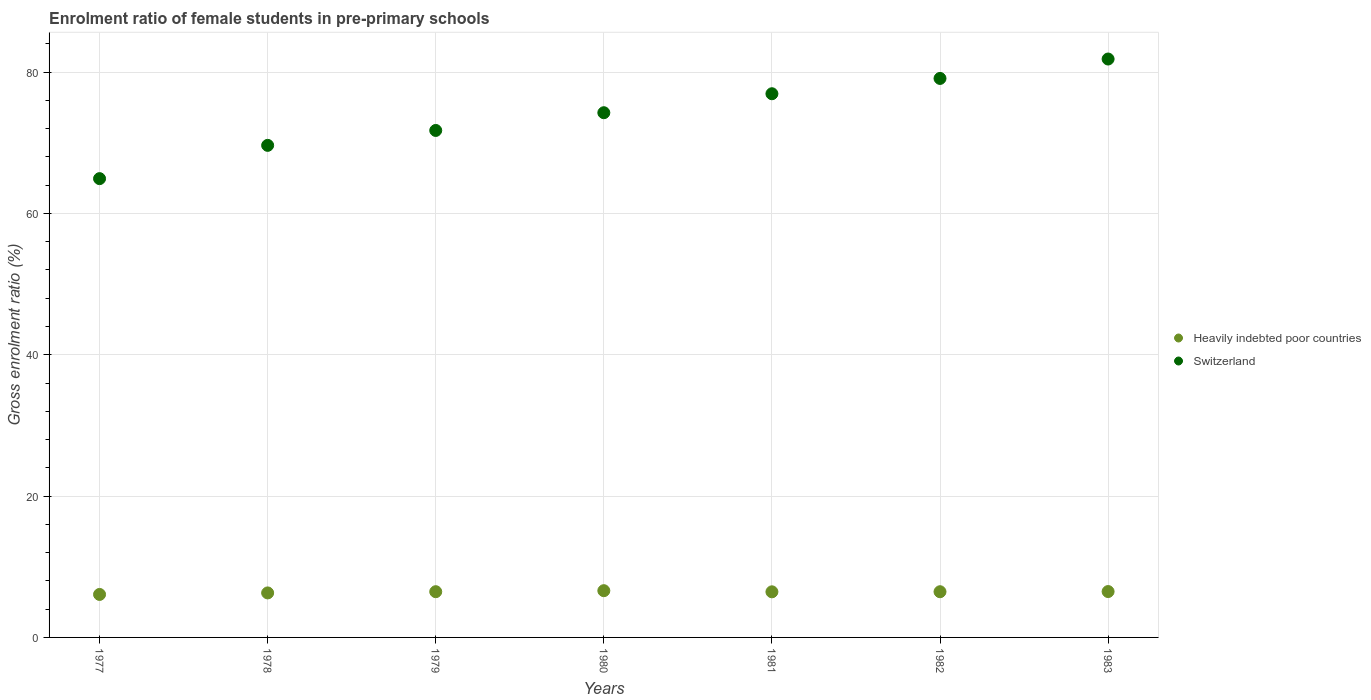Is the number of dotlines equal to the number of legend labels?
Offer a terse response. Yes. What is the enrolment ratio of female students in pre-primary schools in Heavily indebted poor countries in 1979?
Give a very brief answer. 6.47. Across all years, what is the maximum enrolment ratio of female students in pre-primary schools in Switzerland?
Give a very brief answer. 81.85. Across all years, what is the minimum enrolment ratio of female students in pre-primary schools in Switzerland?
Your answer should be compact. 64.92. In which year was the enrolment ratio of female students in pre-primary schools in Heavily indebted poor countries maximum?
Your answer should be compact. 1980. In which year was the enrolment ratio of female students in pre-primary schools in Heavily indebted poor countries minimum?
Offer a very short reply. 1977. What is the total enrolment ratio of female students in pre-primary schools in Heavily indebted poor countries in the graph?
Offer a very short reply. 44.88. What is the difference between the enrolment ratio of female students in pre-primary schools in Heavily indebted poor countries in 1978 and that in 1981?
Provide a short and direct response. -0.16. What is the difference between the enrolment ratio of female students in pre-primary schools in Heavily indebted poor countries in 1981 and the enrolment ratio of female students in pre-primary schools in Switzerland in 1982?
Provide a succinct answer. -72.65. What is the average enrolment ratio of female students in pre-primary schools in Heavily indebted poor countries per year?
Offer a very short reply. 6.41. In the year 1978, what is the difference between the enrolment ratio of female students in pre-primary schools in Switzerland and enrolment ratio of female students in pre-primary schools in Heavily indebted poor countries?
Offer a very short reply. 63.33. What is the ratio of the enrolment ratio of female students in pre-primary schools in Heavily indebted poor countries in 1977 to that in 1979?
Offer a terse response. 0.94. Is the enrolment ratio of female students in pre-primary schools in Switzerland in 1977 less than that in 1983?
Keep it short and to the point. Yes. Is the difference between the enrolment ratio of female students in pre-primary schools in Switzerland in 1978 and 1980 greater than the difference between the enrolment ratio of female students in pre-primary schools in Heavily indebted poor countries in 1978 and 1980?
Your response must be concise. No. What is the difference between the highest and the second highest enrolment ratio of female students in pre-primary schools in Heavily indebted poor countries?
Keep it short and to the point. 0.12. What is the difference between the highest and the lowest enrolment ratio of female students in pre-primary schools in Switzerland?
Give a very brief answer. 16.93. In how many years, is the enrolment ratio of female students in pre-primary schools in Switzerland greater than the average enrolment ratio of female students in pre-primary schools in Switzerland taken over all years?
Your answer should be compact. 4. Is the sum of the enrolment ratio of female students in pre-primary schools in Heavily indebted poor countries in 1978 and 1982 greater than the maximum enrolment ratio of female students in pre-primary schools in Switzerland across all years?
Ensure brevity in your answer.  No. Does the enrolment ratio of female students in pre-primary schools in Heavily indebted poor countries monotonically increase over the years?
Give a very brief answer. No. Is the enrolment ratio of female students in pre-primary schools in Heavily indebted poor countries strictly greater than the enrolment ratio of female students in pre-primary schools in Switzerland over the years?
Your answer should be compact. No. How many dotlines are there?
Your response must be concise. 2. How many years are there in the graph?
Your answer should be compact. 7. What is the difference between two consecutive major ticks on the Y-axis?
Offer a very short reply. 20. What is the title of the graph?
Make the answer very short. Enrolment ratio of female students in pre-primary schools. Does "Ireland" appear as one of the legend labels in the graph?
Offer a terse response. No. What is the label or title of the X-axis?
Ensure brevity in your answer.  Years. What is the Gross enrolment ratio (%) of Heavily indebted poor countries in 1977?
Provide a short and direct response. 6.08. What is the Gross enrolment ratio (%) of Switzerland in 1977?
Provide a succinct answer. 64.92. What is the Gross enrolment ratio (%) of Heavily indebted poor countries in 1978?
Offer a very short reply. 6.3. What is the Gross enrolment ratio (%) of Switzerland in 1978?
Ensure brevity in your answer.  69.63. What is the Gross enrolment ratio (%) in Heavily indebted poor countries in 1979?
Offer a very short reply. 6.47. What is the Gross enrolment ratio (%) in Switzerland in 1979?
Offer a terse response. 71.74. What is the Gross enrolment ratio (%) in Heavily indebted poor countries in 1980?
Your answer should be very brief. 6.61. What is the Gross enrolment ratio (%) in Switzerland in 1980?
Offer a terse response. 74.25. What is the Gross enrolment ratio (%) in Heavily indebted poor countries in 1981?
Make the answer very short. 6.45. What is the Gross enrolment ratio (%) of Switzerland in 1981?
Provide a succinct answer. 76.93. What is the Gross enrolment ratio (%) in Heavily indebted poor countries in 1982?
Ensure brevity in your answer.  6.47. What is the Gross enrolment ratio (%) of Switzerland in 1982?
Provide a succinct answer. 79.1. What is the Gross enrolment ratio (%) of Heavily indebted poor countries in 1983?
Give a very brief answer. 6.49. What is the Gross enrolment ratio (%) of Switzerland in 1983?
Give a very brief answer. 81.85. Across all years, what is the maximum Gross enrolment ratio (%) of Heavily indebted poor countries?
Make the answer very short. 6.61. Across all years, what is the maximum Gross enrolment ratio (%) in Switzerland?
Provide a succinct answer. 81.85. Across all years, what is the minimum Gross enrolment ratio (%) in Heavily indebted poor countries?
Keep it short and to the point. 6.08. Across all years, what is the minimum Gross enrolment ratio (%) in Switzerland?
Provide a succinct answer. 64.92. What is the total Gross enrolment ratio (%) in Heavily indebted poor countries in the graph?
Make the answer very short. 44.88. What is the total Gross enrolment ratio (%) in Switzerland in the graph?
Make the answer very short. 518.42. What is the difference between the Gross enrolment ratio (%) of Heavily indebted poor countries in 1977 and that in 1978?
Provide a succinct answer. -0.21. What is the difference between the Gross enrolment ratio (%) of Switzerland in 1977 and that in 1978?
Ensure brevity in your answer.  -4.71. What is the difference between the Gross enrolment ratio (%) in Heavily indebted poor countries in 1977 and that in 1979?
Ensure brevity in your answer.  -0.39. What is the difference between the Gross enrolment ratio (%) in Switzerland in 1977 and that in 1979?
Offer a very short reply. -6.82. What is the difference between the Gross enrolment ratio (%) in Heavily indebted poor countries in 1977 and that in 1980?
Your response must be concise. -0.53. What is the difference between the Gross enrolment ratio (%) of Switzerland in 1977 and that in 1980?
Make the answer very short. -9.33. What is the difference between the Gross enrolment ratio (%) in Heavily indebted poor countries in 1977 and that in 1981?
Your answer should be very brief. -0.37. What is the difference between the Gross enrolment ratio (%) in Switzerland in 1977 and that in 1981?
Keep it short and to the point. -12.01. What is the difference between the Gross enrolment ratio (%) of Heavily indebted poor countries in 1977 and that in 1982?
Provide a short and direct response. -0.38. What is the difference between the Gross enrolment ratio (%) in Switzerland in 1977 and that in 1982?
Offer a very short reply. -14.18. What is the difference between the Gross enrolment ratio (%) in Heavily indebted poor countries in 1977 and that in 1983?
Offer a terse response. -0.41. What is the difference between the Gross enrolment ratio (%) in Switzerland in 1977 and that in 1983?
Provide a short and direct response. -16.93. What is the difference between the Gross enrolment ratio (%) in Heavily indebted poor countries in 1978 and that in 1979?
Offer a terse response. -0.17. What is the difference between the Gross enrolment ratio (%) in Switzerland in 1978 and that in 1979?
Your answer should be very brief. -2.11. What is the difference between the Gross enrolment ratio (%) in Heavily indebted poor countries in 1978 and that in 1980?
Make the answer very short. -0.32. What is the difference between the Gross enrolment ratio (%) in Switzerland in 1978 and that in 1980?
Make the answer very short. -4.62. What is the difference between the Gross enrolment ratio (%) of Heavily indebted poor countries in 1978 and that in 1981?
Your answer should be very brief. -0.16. What is the difference between the Gross enrolment ratio (%) in Switzerland in 1978 and that in 1981?
Offer a very short reply. -7.3. What is the difference between the Gross enrolment ratio (%) of Heavily indebted poor countries in 1978 and that in 1982?
Make the answer very short. -0.17. What is the difference between the Gross enrolment ratio (%) of Switzerland in 1978 and that in 1982?
Ensure brevity in your answer.  -9.47. What is the difference between the Gross enrolment ratio (%) of Heavily indebted poor countries in 1978 and that in 1983?
Offer a terse response. -0.19. What is the difference between the Gross enrolment ratio (%) of Switzerland in 1978 and that in 1983?
Your response must be concise. -12.22. What is the difference between the Gross enrolment ratio (%) in Heavily indebted poor countries in 1979 and that in 1980?
Your answer should be very brief. -0.14. What is the difference between the Gross enrolment ratio (%) of Switzerland in 1979 and that in 1980?
Offer a terse response. -2.51. What is the difference between the Gross enrolment ratio (%) in Heavily indebted poor countries in 1979 and that in 1981?
Keep it short and to the point. 0.02. What is the difference between the Gross enrolment ratio (%) of Switzerland in 1979 and that in 1981?
Your response must be concise. -5.19. What is the difference between the Gross enrolment ratio (%) in Heavily indebted poor countries in 1979 and that in 1982?
Offer a very short reply. 0. What is the difference between the Gross enrolment ratio (%) of Switzerland in 1979 and that in 1982?
Your answer should be compact. -7.36. What is the difference between the Gross enrolment ratio (%) in Heavily indebted poor countries in 1979 and that in 1983?
Give a very brief answer. -0.02. What is the difference between the Gross enrolment ratio (%) of Switzerland in 1979 and that in 1983?
Provide a short and direct response. -10.11. What is the difference between the Gross enrolment ratio (%) in Heavily indebted poor countries in 1980 and that in 1981?
Your answer should be compact. 0.16. What is the difference between the Gross enrolment ratio (%) of Switzerland in 1980 and that in 1981?
Offer a very short reply. -2.68. What is the difference between the Gross enrolment ratio (%) in Heavily indebted poor countries in 1980 and that in 1982?
Your answer should be compact. 0.15. What is the difference between the Gross enrolment ratio (%) of Switzerland in 1980 and that in 1982?
Offer a very short reply. -4.85. What is the difference between the Gross enrolment ratio (%) of Heavily indebted poor countries in 1980 and that in 1983?
Provide a succinct answer. 0.12. What is the difference between the Gross enrolment ratio (%) of Switzerland in 1980 and that in 1983?
Provide a short and direct response. -7.6. What is the difference between the Gross enrolment ratio (%) in Heavily indebted poor countries in 1981 and that in 1982?
Your answer should be very brief. -0.01. What is the difference between the Gross enrolment ratio (%) in Switzerland in 1981 and that in 1982?
Make the answer very short. -2.17. What is the difference between the Gross enrolment ratio (%) in Heavily indebted poor countries in 1981 and that in 1983?
Make the answer very short. -0.04. What is the difference between the Gross enrolment ratio (%) in Switzerland in 1981 and that in 1983?
Offer a very short reply. -4.91. What is the difference between the Gross enrolment ratio (%) in Heavily indebted poor countries in 1982 and that in 1983?
Provide a succinct answer. -0.03. What is the difference between the Gross enrolment ratio (%) in Switzerland in 1982 and that in 1983?
Offer a very short reply. -2.75. What is the difference between the Gross enrolment ratio (%) of Heavily indebted poor countries in 1977 and the Gross enrolment ratio (%) of Switzerland in 1978?
Your answer should be compact. -63.55. What is the difference between the Gross enrolment ratio (%) of Heavily indebted poor countries in 1977 and the Gross enrolment ratio (%) of Switzerland in 1979?
Offer a very short reply. -65.66. What is the difference between the Gross enrolment ratio (%) of Heavily indebted poor countries in 1977 and the Gross enrolment ratio (%) of Switzerland in 1980?
Give a very brief answer. -68.17. What is the difference between the Gross enrolment ratio (%) of Heavily indebted poor countries in 1977 and the Gross enrolment ratio (%) of Switzerland in 1981?
Offer a very short reply. -70.85. What is the difference between the Gross enrolment ratio (%) in Heavily indebted poor countries in 1977 and the Gross enrolment ratio (%) in Switzerland in 1982?
Ensure brevity in your answer.  -73.02. What is the difference between the Gross enrolment ratio (%) of Heavily indebted poor countries in 1977 and the Gross enrolment ratio (%) of Switzerland in 1983?
Ensure brevity in your answer.  -75.76. What is the difference between the Gross enrolment ratio (%) in Heavily indebted poor countries in 1978 and the Gross enrolment ratio (%) in Switzerland in 1979?
Your answer should be compact. -65.44. What is the difference between the Gross enrolment ratio (%) in Heavily indebted poor countries in 1978 and the Gross enrolment ratio (%) in Switzerland in 1980?
Provide a succinct answer. -67.95. What is the difference between the Gross enrolment ratio (%) in Heavily indebted poor countries in 1978 and the Gross enrolment ratio (%) in Switzerland in 1981?
Make the answer very short. -70.64. What is the difference between the Gross enrolment ratio (%) in Heavily indebted poor countries in 1978 and the Gross enrolment ratio (%) in Switzerland in 1982?
Provide a short and direct response. -72.8. What is the difference between the Gross enrolment ratio (%) in Heavily indebted poor countries in 1978 and the Gross enrolment ratio (%) in Switzerland in 1983?
Make the answer very short. -75.55. What is the difference between the Gross enrolment ratio (%) in Heavily indebted poor countries in 1979 and the Gross enrolment ratio (%) in Switzerland in 1980?
Give a very brief answer. -67.78. What is the difference between the Gross enrolment ratio (%) of Heavily indebted poor countries in 1979 and the Gross enrolment ratio (%) of Switzerland in 1981?
Make the answer very short. -70.46. What is the difference between the Gross enrolment ratio (%) of Heavily indebted poor countries in 1979 and the Gross enrolment ratio (%) of Switzerland in 1982?
Your response must be concise. -72.63. What is the difference between the Gross enrolment ratio (%) in Heavily indebted poor countries in 1979 and the Gross enrolment ratio (%) in Switzerland in 1983?
Give a very brief answer. -75.38. What is the difference between the Gross enrolment ratio (%) of Heavily indebted poor countries in 1980 and the Gross enrolment ratio (%) of Switzerland in 1981?
Ensure brevity in your answer.  -70.32. What is the difference between the Gross enrolment ratio (%) in Heavily indebted poor countries in 1980 and the Gross enrolment ratio (%) in Switzerland in 1982?
Provide a short and direct response. -72.49. What is the difference between the Gross enrolment ratio (%) in Heavily indebted poor countries in 1980 and the Gross enrolment ratio (%) in Switzerland in 1983?
Your answer should be very brief. -75.23. What is the difference between the Gross enrolment ratio (%) of Heavily indebted poor countries in 1981 and the Gross enrolment ratio (%) of Switzerland in 1982?
Offer a terse response. -72.65. What is the difference between the Gross enrolment ratio (%) in Heavily indebted poor countries in 1981 and the Gross enrolment ratio (%) in Switzerland in 1983?
Make the answer very short. -75.39. What is the difference between the Gross enrolment ratio (%) in Heavily indebted poor countries in 1982 and the Gross enrolment ratio (%) in Switzerland in 1983?
Your answer should be compact. -75.38. What is the average Gross enrolment ratio (%) of Heavily indebted poor countries per year?
Your response must be concise. 6.41. What is the average Gross enrolment ratio (%) in Switzerland per year?
Keep it short and to the point. 74.06. In the year 1977, what is the difference between the Gross enrolment ratio (%) in Heavily indebted poor countries and Gross enrolment ratio (%) in Switzerland?
Keep it short and to the point. -58.84. In the year 1978, what is the difference between the Gross enrolment ratio (%) in Heavily indebted poor countries and Gross enrolment ratio (%) in Switzerland?
Offer a terse response. -63.33. In the year 1979, what is the difference between the Gross enrolment ratio (%) of Heavily indebted poor countries and Gross enrolment ratio (%) of Switzerland?
Your answer should be compact. -65.27. In the year 1980, what is the difference between the Gross enrolment ratio (%) of Heavily indebted poor countries and Gross enrolment ratio (%) of Switzerland?
Ensure brevity in your answer.  -67.63. In the year 1981, what is the difference between the Gross enrolment ratio (%) in Heavily indebted poor countries and Gross enrolment ratio (%) in Switzerland?
Your answer should be very brief. -70.48. In the year 1982, what is the difference between the Gross enrolment ratio (%) of Heavily indebted poor countries and Gross enrolment ratio (%) of Switzerland?
Give a very brief answer. -72.63. In the year 1983, what is the difference between the Gross enrolment ratio (%) of Heavily indebted poor countries and Gross enrolment ratio (%) of Switzerland?
Your response must be concise. -75.36. What is the ratio of the Gross enrolment ratio (%) of Heavily indebted poor countries in 1977 to that in 1978?
Make the answer very short. 0.97. What is the ratio of the Gross enrolment ratio (%) of Switzerland in 1977 to that in 1978?
Make the answer very short. 0.93. What is the ratio of the Gross enrolment ratio (%) in Switzerland in 1977 to that in 1979?
Make the answer very short. 0.91. What is the ratio of the Gross enrolment ratio (%) in Heavily indebted poor countries in 1977 to that in 1980?
Make the answer very short. 0.92. What is the ratio of the Gross enrolment ratio (%) in Switzerland in 1977 to that in 1980?
Offer a very short reply. 0.87. What is the ratio of the Gross enrolment ratio (%) in Heavily indebted poor countries in 1977 to that in 1981?
Offer a very short reply. 0.94. What is the ratio of the Gross enrolment ratio (%) in Switzerland in 1977 to that in 1981?
Provide a short and direct response. 0.84. What is the ratio of the Gross enrolment ratio (%) in Heavily indebted poor countries in 1977 to that in 1982?
Your answer should be compact. 0.94. What is the ratio of the Gross enrolment ratio (%) in Switzerland in 1977 to that in 1982?
Provide a succinct answer. 0.82. What is the ratio of the Gross enrolment ratio (%) in Heavily indebted poor countries in 1977 to that in 1983?
Keep it short and to the point. 0.94. What is the ratio of the Gross enrolment ratio (%) in Switzerland in 1977 to that in 1983?
Your answer should be compact. 0.79. What is the ratio of the Gross enrolment ratio (%) of Heavily indebted poor countries in 1978 to that in 1979?
Ensure brevity in your answer.  0.97. What is the ratio of the Gross enrolment ratio (%) of Switzerland in 1978 to that in 1979?
Ensure brevity in your answer.  0.97. What is the ratio of the Gross enrolment ratio (%) in Heavily indebted poor countries in 1978 to that in 1980?
Provide a short and direct response. 0.95. What is the ratio of the Gross enrolment ratio (%) of Switzerland in 1978 to that in 1980?
Keep it short and to the point. 0.94. What is the ratio of the Gross enrolment ratio (%) of Switzerland in 1978 to that in 1981?
Offer a terse response. 0.91. What is the ratio of the Gross enrolment ratio (%) of Heavily indebted poor countries in 1978 to that in 1982?
Your response must be concise. 0.97. What is the ratio of the Gross enrolment ratio (%) of Switzerland in 1978 to that in 1982?
Offer a very short reply. 0.88. What is the ratio of the Gross enrolment ratio (%) in Heavily indebted poor countries in 1978 to that in 1983?
Give a very brief answer. 0.97. What is the ratio of the Gross enrolment ratio (%) in Switzerland in 1978 to that in 1983?
Your answer should be very brief. 0.85. What is the ratio of the Gross enrolment ratio (%) of Heavily indebted poor countries in 1979 to that in 1980?
Keep it short and to the point. 0.98. What is the ratio of the Gross enrolment ratio (%) in Switzerland in 1979 to that in 1980?
Offer a very short reply. 0.97. What is the ratio of the Gross enrolment ratio (%) in Switzerland in 1979 to that in 1981?
Your response must be concise. 0.93. What is the ratio of the Gross enrolment ratio (%) in Heavily indebted poor countries in 1979 to that in 1982?
Keep it short and to the point. 1. What is the ratio of the Gross enrolment ratio (%) in Switzerland in 1979 to that in 1982?
Offer a terse response. 0.91. What is the ratio of the Gross enrolment ratio (%) in Heavily indebted poor countries in 1979 to that in 1983?
Offer a very short reply. 1. What is the ratio of the Gross enrolment ratio (%) in Switzerland in 1979 to that in 1983?
Offer a very short reply. 0.88. What is the ratio of the Gross enrolment ratio (%) in Heavily indebted poor countries in 1980 to that in 1981?
Provide a short and direct response. 1.02. What is the ratio of the Gross enrolment ratio (%) of Switzerland in 1980 to that in 1981?
Provide a short and direct response. 0.97. What is the ratio of the Gross enrolment ratio (%) of Heavily indebted poor countries in 1980 to that in 1982?
Offer a terse response. 1.02. What is the ratio of the Gross enrolment ratio (%) in Switzerland in 1980 to that in 1982?
Keep it short and to the point. 0.94. What is the ratio of the Gross enrolment ratio (%) in Heavily indebted poor countries in 1980 to that in 1983?
Your answer should be compact. 1.02. What is the ratio of the Gross enrolment ratio (%) of Switzerland in 1980 to that in 1983?
Your response must be concise. 0.91. What is the ratio of the Gross enrolment ratio (%) in Heavily indebted poor countries in 1981 to that in 1982?
Give a very brief answer. 1. What is the ratio of the Gross enrolment ratio (%) in Switzerland in 1981 to that in 1982?
Offer a terse response. 0.97. What is the ratio of the Gross enrolment ratio (%) of Heavily indebted poor countries in 1981 to that in 1983?
Provide a short and direct response. 0.99. What is the ratio of the Gross enrolment ratio (%) of Switzerland in 1981 to that in 1983?
Your response must be concise. 0.94. What is the ratio of the Gross enrolment ratio (%) in Switzerland in 1982 to that in 1983?
Provide a short and direct response. 0.97. What is the difference between the highest and the second highest Gross enrolment ratio (%) of Heavily indebted poor countries?
Your answer should be compact. 0.12. What is the difference between the highest and the second highest Gross enrolment ratio (%) of Switzerland?
Make the answer very short. 2.75. What is the difference between the highest and the lowest Gross enrolment ratio (%) of Heavily indebted poor countries?
Ensure brevity in your answer.  0.53. What is the difference between the highest and the lowest Gross enrolment ratio (%) in Switzerland?
Ensure brevity in your answer.  16.93. 